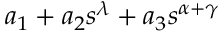Convert formula to latex. <formula><loc_0><loc_0><loc_500><loc_500>a _ { 1 } + a _ { 2 } s ^ { \lambda } + a _ { 3 } s ^ { \alpha + \gamma }</formula> 